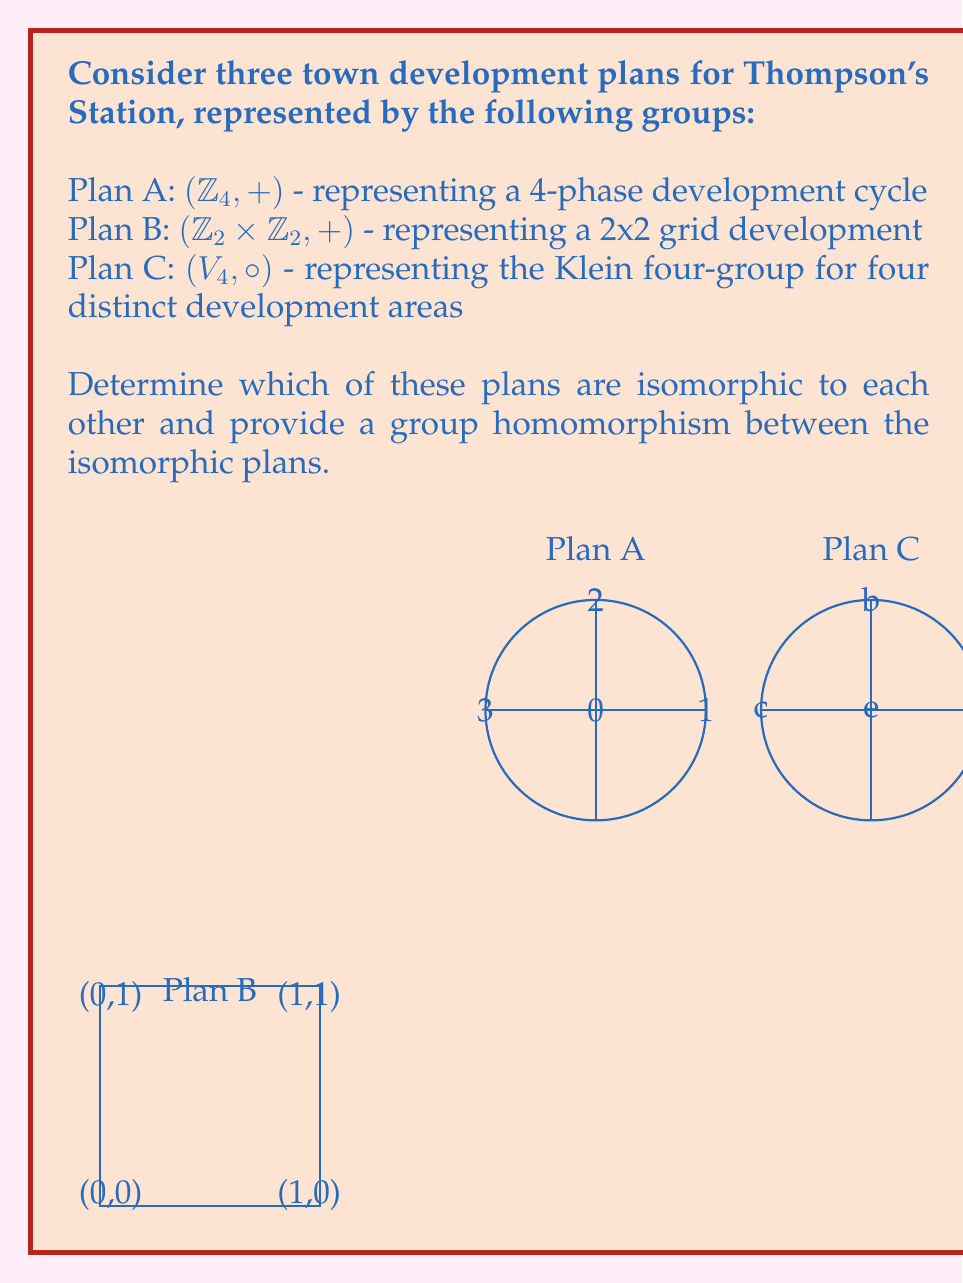What is the answer to this math problem? To determine which plans are isomorphic, we need to compare their group structures:

1) First, let's examine the order of each group:
   - Plan A: $|\mathbb{Z}_4| = 4$
   - Plan B: $|\mathbb{Z}_2 \times \mathbb{Z}_2| = 4$
   - Plan C: $|V_4| = 4$

   All groups have order 4, so they could potentially be isomorphic.

2) Now, let's look at the element orders:
   - Plan A: orders are 1, 2, 4, 4
   - Plan B: orders are 1, 2, 2, 2
   - Plan C: orders are 1, 2, 2, 2

3) From this, we can conclude that Plan B and Plan C are potentially isomorphic, while Plan A is not isomorphic to either B or C.

4) To prove that B and C are isomorphic, we need to find a bijective homomorphism between them. Let's define:

   $\phi: \mathbb{Z}_2 \times \mathbb{Z}_2 \rightarrow V_4$
   
   $\phi(0,0) = e$
   $\phi(1,0) = a$
   $\phi(0,1) = b$
   $\phi(1,1) = c$

5) To verify this is a homomorphism, we need to check that $\phi(x+y) = \phi(x) \circ \phi(y)$ for all $x,y \in \mathbb{Z}_2 \times \mathbb{Z}_2$. 

   For example: $\phi((1,0) + (0,1)) = \phi(1,1) = c$
                $\phi(1,0) \circ \phi(0,1) = a \circ b = c$

   This holds for all combinations, confirming that $\phi$ is a homomorphism.

6) $\phi$ is bijective as it maps each element of $\mathbb{Z}_2 \times \mathbb{Z}_2$ to a unique element of $V_4$.

Therefore, Plan B and Plan C are isomorphic, while Plan A is not isomorphic to either B or C.
Answer: Plans B and C are isomorphic. $\phi: \mathbb{Z}_2 \times \mathbb{Z}_2 \rightarrow V_4$, $\phi(a,b) = a \cdot b$ is an isomorphism. 